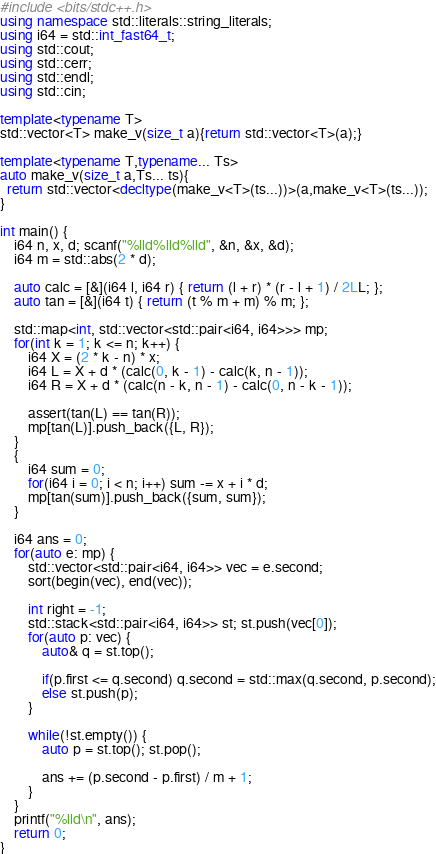Convert code to text. <code><loc_0><loc_0><loc_500><loc_500><_C++_>#include <bits/stdc++.h>
using namespace std::literals::string_literals;
using i64 = std::int_fast64_t;
using std::cout;
using std::cerr;
using std::endl;
using std::cin;

template<typename T>
std::vector<T> make_v(size_t a){return std::vector<T>(a);}

template<typename T,typename... Ts>
auto make_v(size_t a,Ts... ts){
  return std::vector<decltype(make_v<T>(ts...))>(a,make_v<T>(ts...));
}

int main() {
	i64 n, x, d; scanf("%lld%lld%lld", &n, &x, &d);
	i64 m = std::abs(2 * d);

	auto calc = [&](i64 l, i64 r) { return (l + r) * (r - l + 1) / 2LL; };
	auto tan = [&](i64 t) { return (t % m + m) % m; };
	
	std::map<int, std::vector<std::pair<i64, i64>>> mp;
	for(int k = 1; k <= n; k++) {
		i64 X = (2 * k - n) * x;
		i64 L = X + d * (calc(0, k - 1) - calc(k, n - 1));
		i64 R = X + d * (calc(n - k, n - 1) - calc(0, n - k - 1));

		assert(tan(L) == tan(R));
		mp[tan(L)].push_back({L, R});
	}
	{
		i64 sum = 0;
		for(i64 i = 0; i < n; i++) sum -= x + i * d;
		mp[tan(sum)].push_back({sum, sum});
	}

	i64 ans = 0;
	for(auto e: mp) {
		std::vector<std::pair<i64, i64>> vec = e.second;
		sort(begin(vec), end(vec));

		int right = -1;
		std::stack<std::pair<i64, i64>> st; st.push(vec[0]);
		for(auto p: vec) {
			auto& q = st.top();

			if(p.first <= q.second) q.second = std::max(q.second, p.second);
			else st.push(p);
		}

		while(!st.empty()) {
			auto p = st.top(); st.pop();
			
			ans += (p.second - p.first) / m + 1;
		}
	}
	printf("%lld\n", ans);
	return 0;
}
</code> 